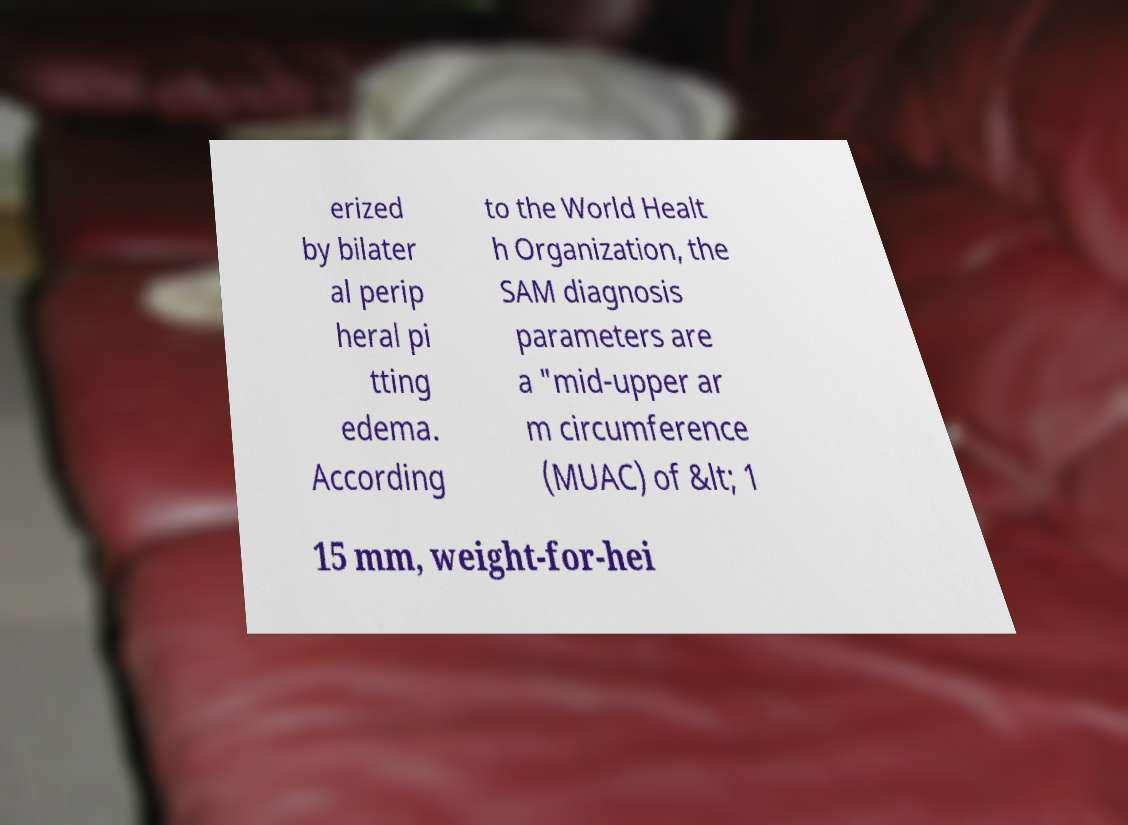I need the written content from this picture converted into text. Can you do that? erized by bilater al perip heral pi tting edema. According to the World Healt h Organization, the SAM diagnosis parameters are a "mid-upper ar m circumference (MUAC) of &lt; 1 15 mm, weight-for-hei 